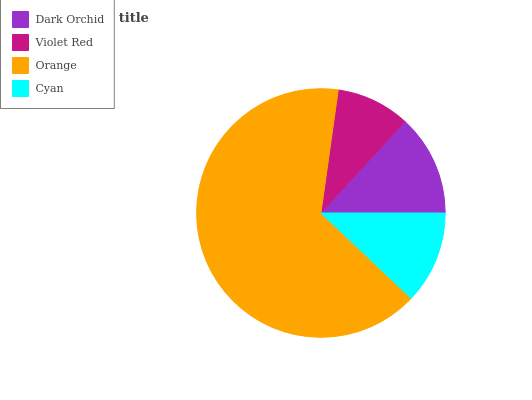Is Violet Red the minimum?
Answer yes or no. Yes. Is Orange the maximum?
Answer yes or no. Yes. Is Orange the minimum?
Answer yes or no. No. Is Violet Red the maximum?
Answer yes or no. No. Is Orange greater than Violet Red?
Answer yes or no. Yes. Is Violet Red less than Orange?
Answer yes or no. Yes. Is Violet Red greater than Orange?
Answer yes or no. No. Is Orange less than Violet Red?
Answer yes or no. No. Is Dark Orchid the high median?
Answer yes or no. Yes. Is Cyan the low median?
Answer yes or no. Yes. Is Orange the high median?
Answer yes or no. No. Is Orange the low median?
Answer yes or no. No. 